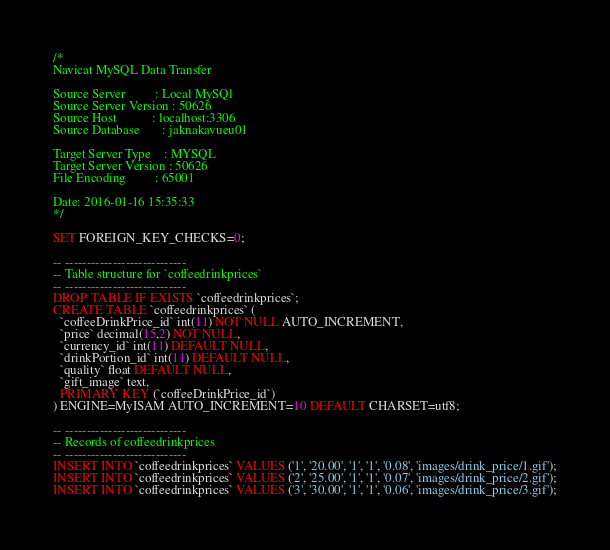<code> <loc_0><loc_0><loc_500><loc_500><_SQL_>/*
Navicat MySQL Data Transfer

Source Server         : Local MySQl
Source Server Version : 50626
Source Host           : localhost:3306
Source Database       : jaknakavueu01

Target Server Type    : MYSQL
Target Server Version : 50626
File Encoding         : 65001

Date: 2016-01-16 15:35:33
*/

SET FOREIGN_KEY_CHECKS=0;

-- ----------------------------
-- Table structure for `coffeedrinkprices`
-- ----------------------------
DROP TABLE IF EXISTS `coffeedrinkprices`;
CREATE TABLE `coffeedrinkprices` (
  `coffeeDrinkPrice_id` int(11) NOT NULL AUTO_INCREMENT,
  `price` decimal(15,2) NOT NULL,
  `currency_id` int(11) DEFAULT NULL,
  `drinkPortion_id` int(11) DEFAULT NULL,
  `quality` float DEFAULT NULL,
  `gift_image` text,
  PRIMARY KEY (`coffeeDrinkPrice_id`)
) ENGINE=MyISAM AUTO_INCREMENT=10 DEFAULT CHARSET=utf8;

-- ----------------------------
-- Records of coffeedrinkprices
-- ----------------------------
INSERT INTO `coffeedrinkprices` VALUES ('1', '20.00', '1', '1', '0.08', 'images/drink_price/1.gif');
INSERT INTO `coffeedrinkprices` VALUES ('2', '25.00', '1', '1', '0.07', 'images/drink_price/2.gif');
INSERT INTO `coffeedrinkprices` VALUES ('3', '30.00', '1', '1', '0.06', 'images/drink_price/3.gif');</code> 